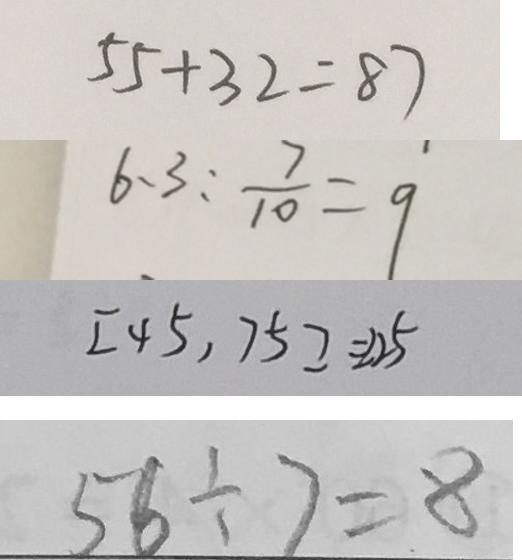<formula> <loc_0><loc_0><loc_500><loc_500>5 5 + 3 2 = 8 7 
 6 、 3 : \frac { 7 } { 1 0 } = 9 
 [ 4 5 , 7 5 ] = 2 2 5 
 5 6 \div 7 = 8</formula> 